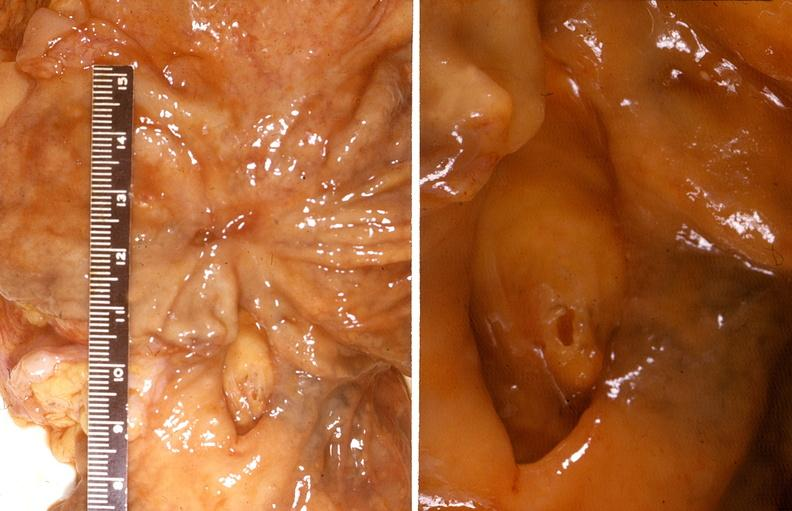where does this belong to?
Answer the question using a single word or phrase. Gastrointestinal system 